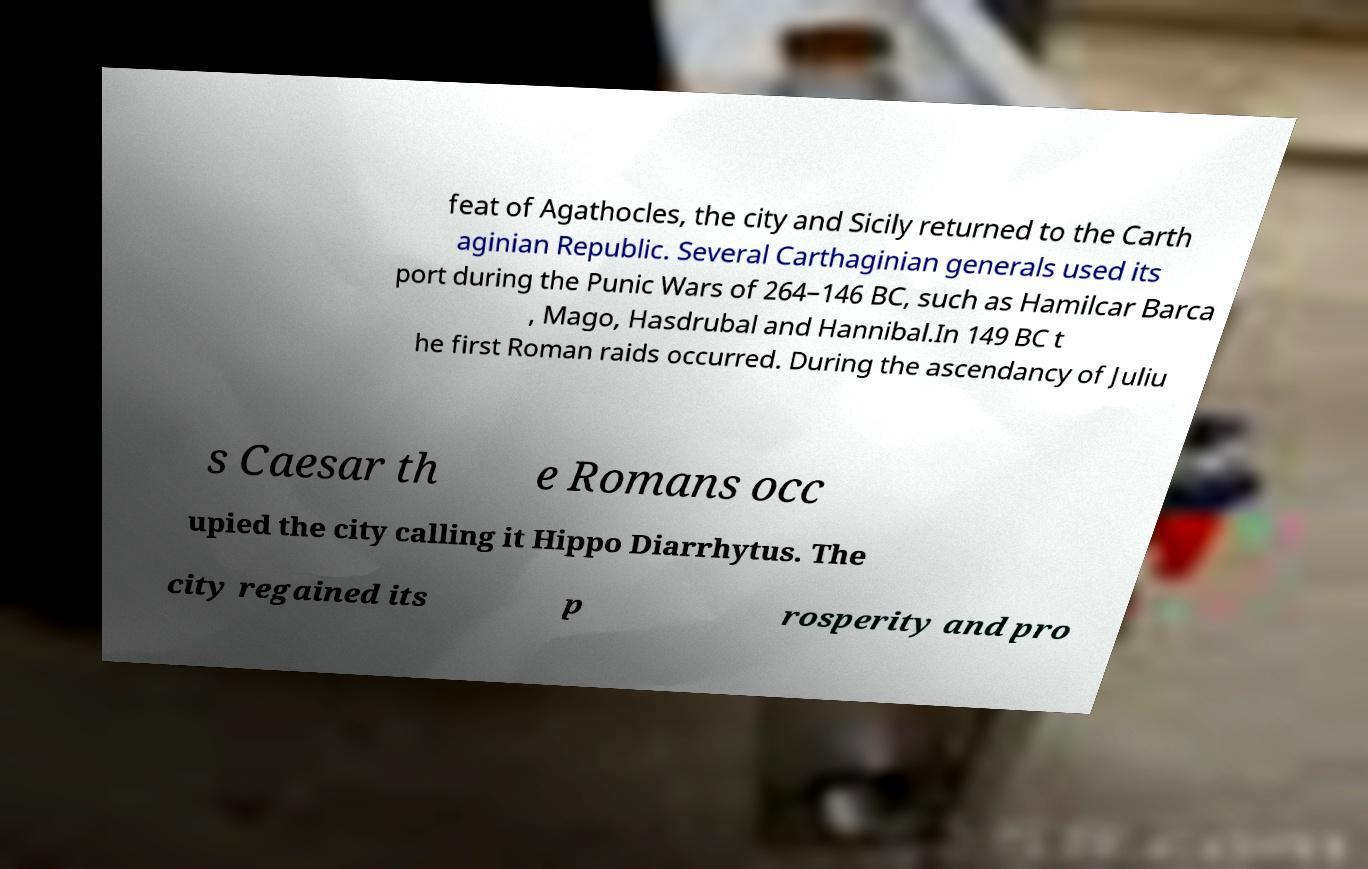For documentation purposes, I need the text within this image transcribed. Could you provide that? feat of Agathocles, the city and Sicily returned to the Carth aginian Republic. Several Carthaginian generals used its port during the Punic Wars of 264–146 BC, such as Hamilcar Barca , Mago, Hasdrubal and Hannibal.In 149 BC t he first Roman raids occurred. During the ascendancy of Juliu s Caesar th e Romans occ upied the city calling it Hippo Diarrhytus. The city regained its p rosperity and pro 